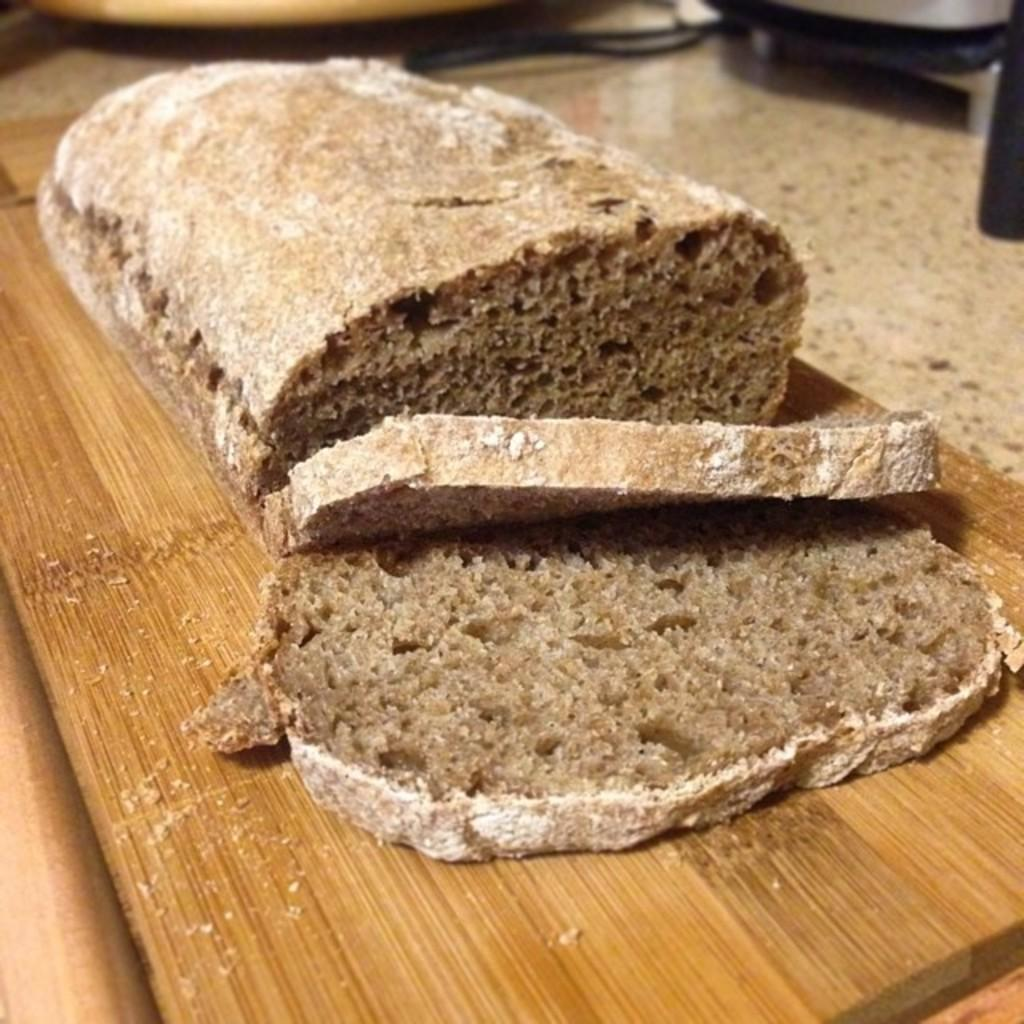What is placed on the wooden plank in the image? There is food on a wooden plank in the image. Can you describe any objects in the background of the image? There are vessels in the background of the image. What type of mitten is being used to serve the food on the wooden plank in the image? There is no mitten present in the image, and it is not being used to serve the food. Can you hear a bell ringing in the image? There is no bell present in the image, and therefore no sound can be heard. 